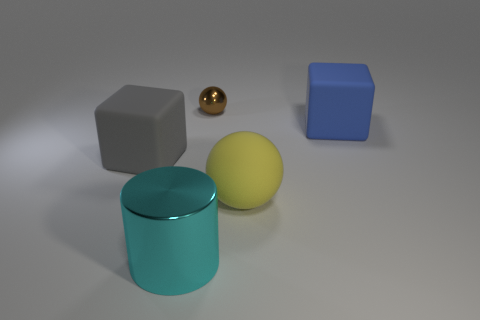Add 1 big green metal cylinders. How many objects exist? 6 Subtract all blocks. How many objects are left? 3 Add 5 tiny brown metal balls. How many tiny brown metal balls are left? 6 Add 4 brown objects. How many brown objects exist? 5 Subtract 1 cyan cylinders. How many objects are left? 4 Subtract all large cyan metal objects. Subtract all big gray objects. How many objects are left? 3 